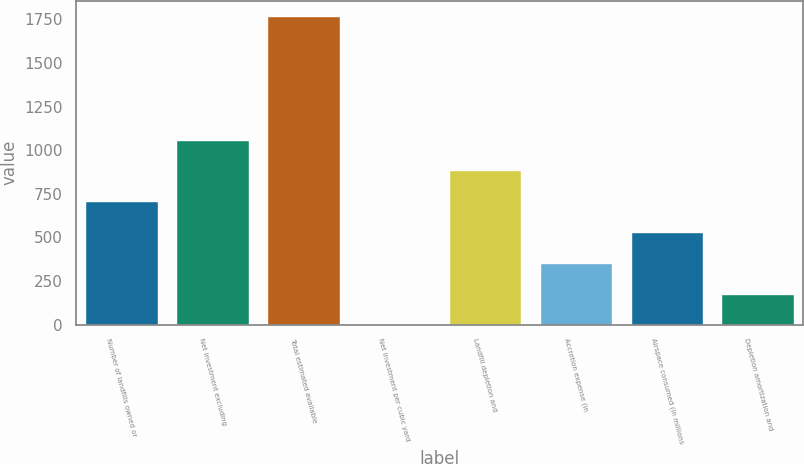<chart> <loc_0><loc_0><loc_500><loc_500><bar_chart><fcel>Number of landfills owned or<fcel>Net investment excluding<fcel>Total estimated available<fcel>Net investment per cubic yard<fcel>Landfill depletion and<fcel>Accretion expense (in<fcel>Airspace consumed (in millions<fcel>Depletion amortization and<nl><fcel>707.19<fcel>1060.57<fcel>1767.3<fcel>0.43<fcel>883.88<fcel>353.81<fcel>530.5<fcel>177.12<nl></chart> 